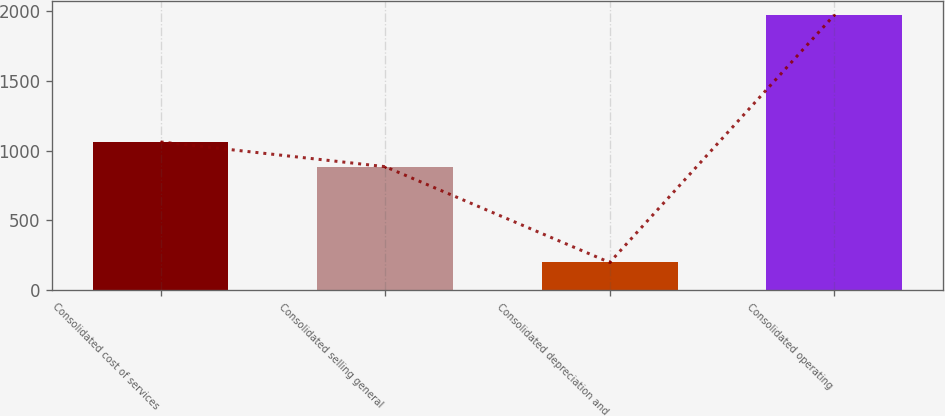Convert chart to OTSL. <chart><loc_0><loc_0><loc_500><loc_500><bar_chart><fcel>Consolidated cost of services<fcel>Consolidated selling general<fcel>Consolidated depreciation and<fcel>Consolidated operating<nl><fcel>1061.47<fcel>884.3<fcel>198<fcel>1969.7<nl></chart> 